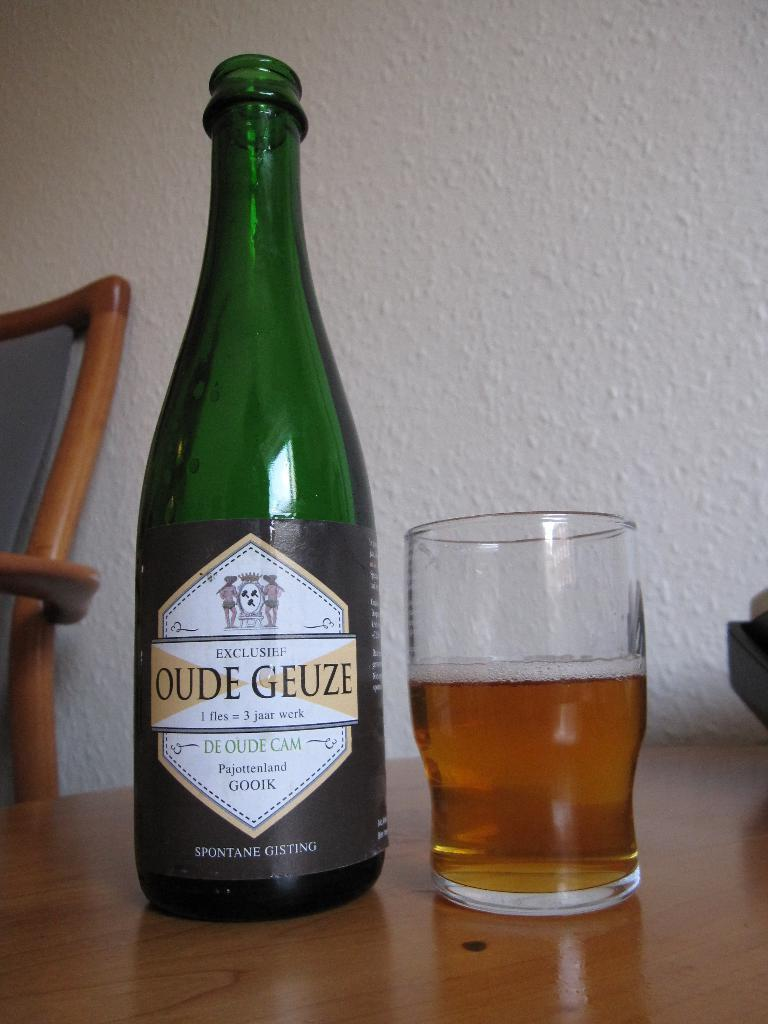<image>
Create a compact narrative representing the image presented. A bottle of Oude Geuze sits next to a half-full glass. 